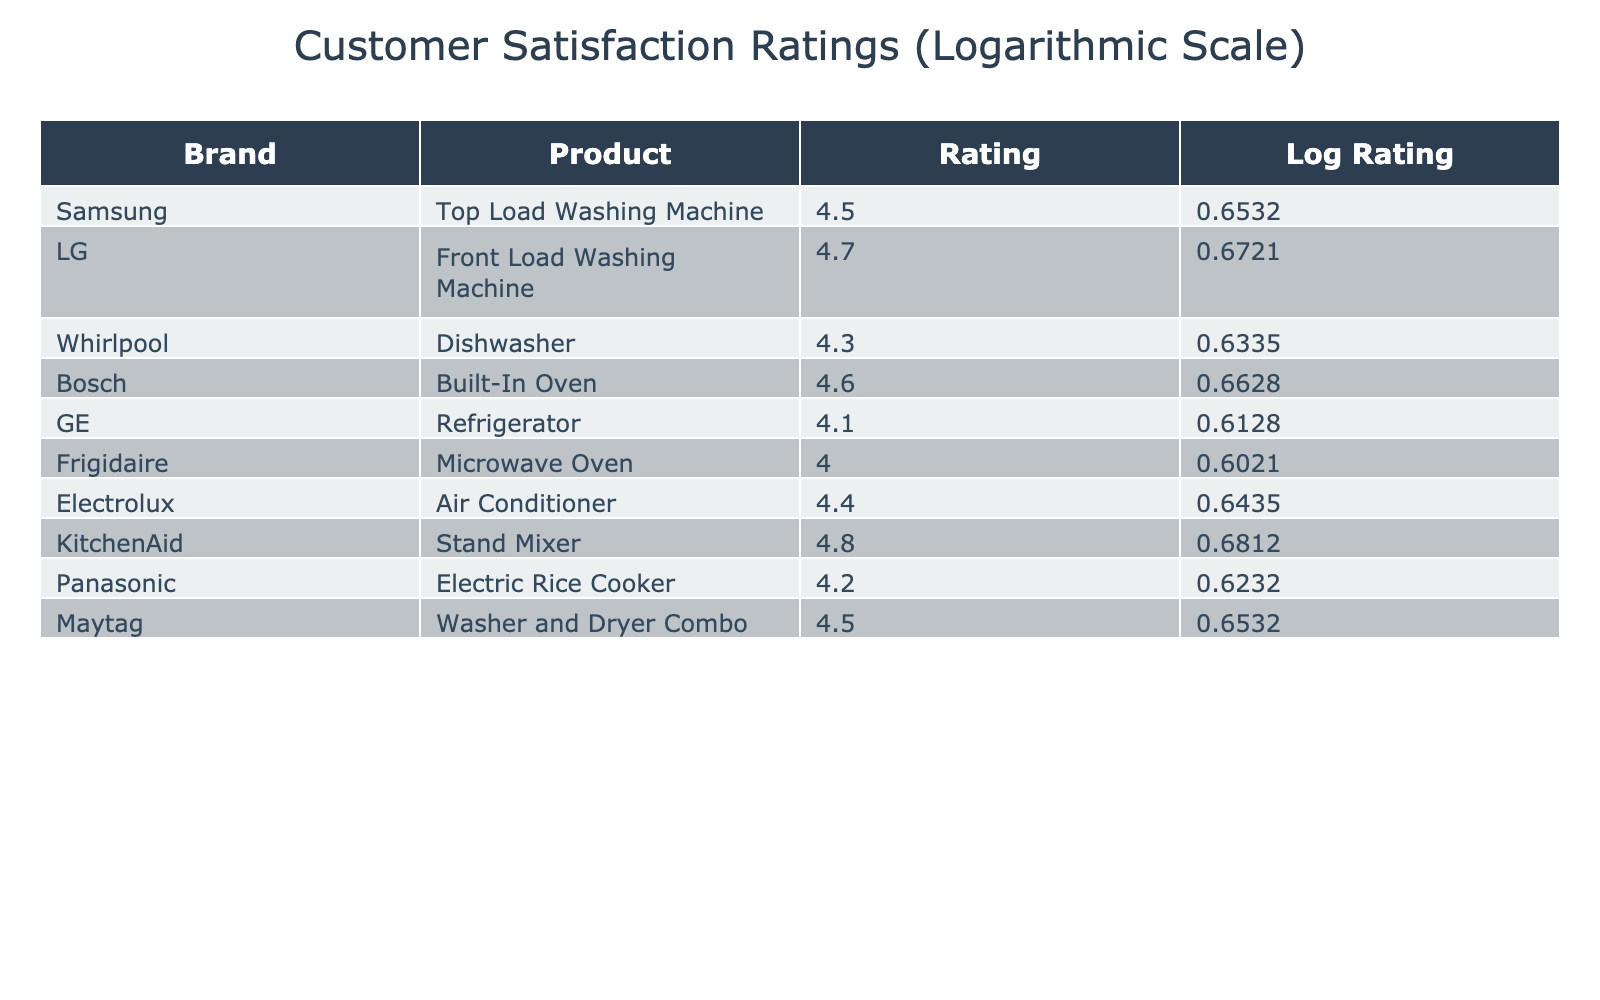What is the customer satisfaction rating of the LG Front Load Washing Machine? According to the table, the LG Front Load Washing Machine has a customer satisfaction rating of 4.7. This information can be found directly within the "Customer_Satisfaction_Rating" column under the row for LG.
Answer: 4.7 Which product has the highest customer satisfaction rating? The table shows that the KitchenAid Stand Mixer has the highest customer satisfaction rating of 4.8. We can identify this by comparing all the ratings listed in the table.
Answer: 4.8 Is the customer satisfaction rating for Bosch's Built-In Oven above 4.5? The rating for Bosch's Built-In Oven is 4.6, which is indeed above 4.5. By directly checking the value in the "Customer_Satisfaction_Rating" column for Bosch, we confirm this.
Answer: Yes What is the average customer satisfaction rating of all products listed in the table? To find the average, we sum all the ratings: 4.5 + 4.7 + 4.3 + 4.6 + 4.1 + 4.0 + 4.4 + 4.8 + 4.2 + 4.5 = 45.1. There are 10 products, so the average is 45.1 / 10 = 4.51.
Answer: 4.51 Which brand has a lower customer satisfaction rating: Frigidaire Microwave Oven or GE Refrigerator? Frigidaire has a customer satisfaction rating of 4.0, while GE has a rating of 4.1. Since 4.0 is less than 4.1, Frigidaire has the lower rating. We compare the values directly from their respective rows in the table.
Answer: Frigidaire Microwave Oven What is the difference between the highest and lowest customer satisfaction ratings? The highest rating is 4.8 (KitchenAid Stand Mixer) and the lowest is 4.0 (Frigidaire Microwave Oven). The difference is 4.8 - 4.0 = 0.8. We find the maximum and minimum values from the ratings and perform subtraction.
Answer: 0.8 Is there a product from Whirlpool with a customer satisfaction rating equal to or greater than 4.5? Whirlpool's Dishwasher has a customer satisfaction rating of 4.3, which is less than 4.5. By confirming the value from Whirlpool's row in the table, we determine the answer.
Answer: No Which two brands have customer satisfaction ratings over 4.5? From the table, LG (4.7) and KitchenAid (4.8) are the only brands with ratings above 4.5. We identify brands by filtering those rows where the rating exceeds 4.5.
Answer: LG and KitchenAid What is the logarithmic rating for the Maytag Washer and Dryer Combo? For the Maytag Washer and Dryer Combo with a customer satisfaction rating of 4.5, the logarithmic rating can be calculated as log10(4.5) which is approximately 0.6532. The value is provided explicitly in the logarithmic rating column.
Answer: 0.6532 